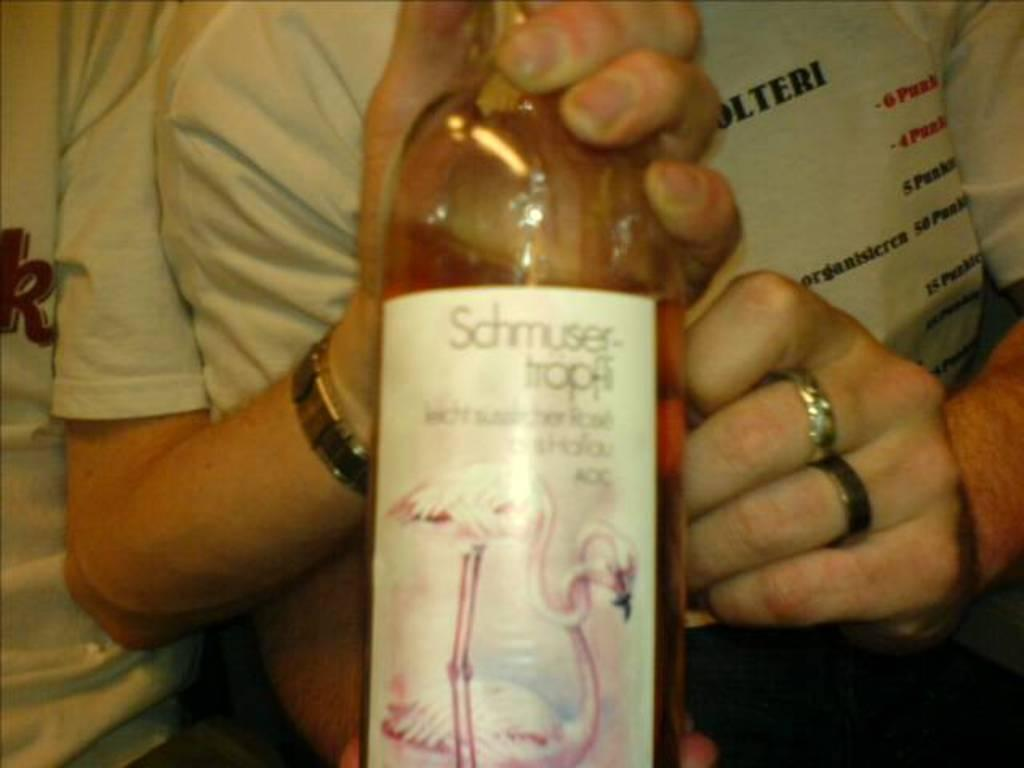<image>
Create a compact narrative representing the image presented. Two left hands from two different people holding onto a wine bottle of Schmuser-tropff Rose. 